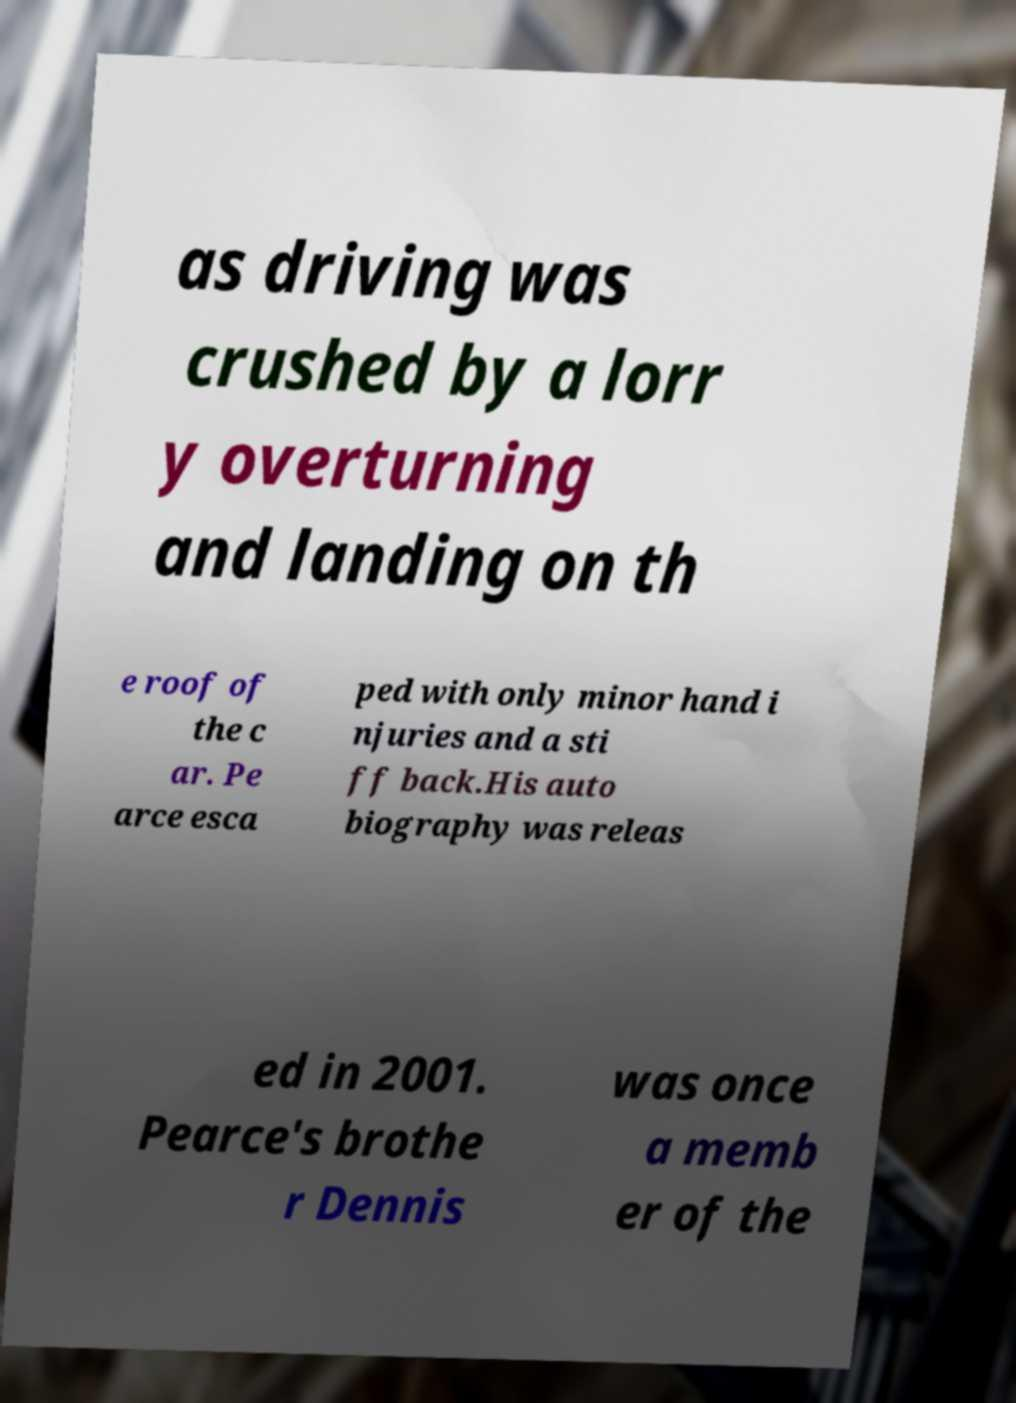Could you extract and type out the text from this image? as driving was crushed by a lorr y overturning and landing on th e roof of the c ar. Pe arce esca ped with only minor hand i njuries and a sti ff back.His auto biography was releas ed in 2001. Pearce's brothe r Dennis was once a memb er of the 